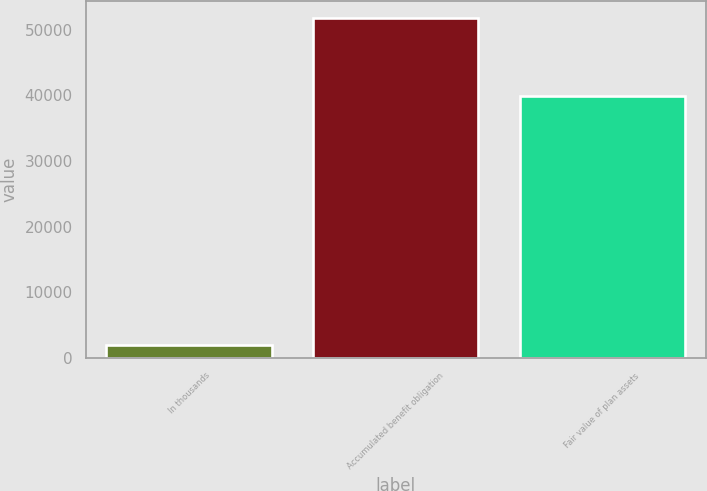Convert chart to OTSL. <chart><loc_0><loc_0><loc_500><loc_500><bar_chart><fcel>In thousands<fcel>Accumulated benefit obligation<fcel>Fair value of plan assets<nl><fcel>2011<fcel>51735<fcel>39951<nl></chart> 